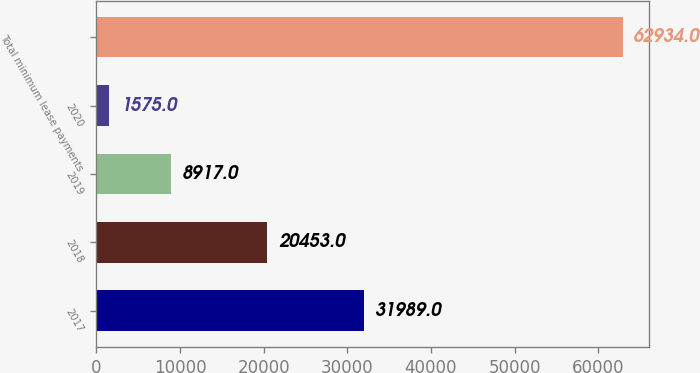Convert chart to OTSL. <chart><loc_0><loc_0><loc_500><loc_500><bar_chart><fcel>2017<fcel>2018<fcel>2019<fcel>2020<fcel>Total minimum lease payments<nl><fcel>31989<fcel>20453<fcel>8917<fcel>1575<fcel>62934<nl></chart> 